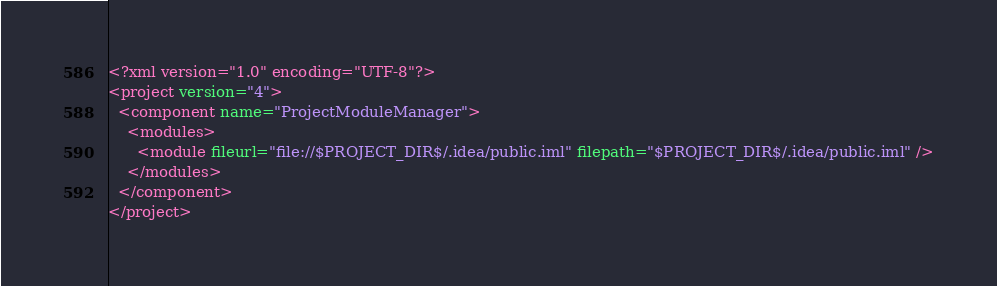Convert code to text. <code><loc_0><loc_0><loc_500><loc_500><_XML_><?xml version="1.0" encoding="UTF-8"?>
<project version="4">
  <component name="ProjectModuleManager">
    <modules>
      <module fileurl="file://$PROJECT_DIR$/.idea/public.iml" filepath="$PROJECT_DIR$/.idea/public.iml" />
    </modules>
  </component>
</project></code> 